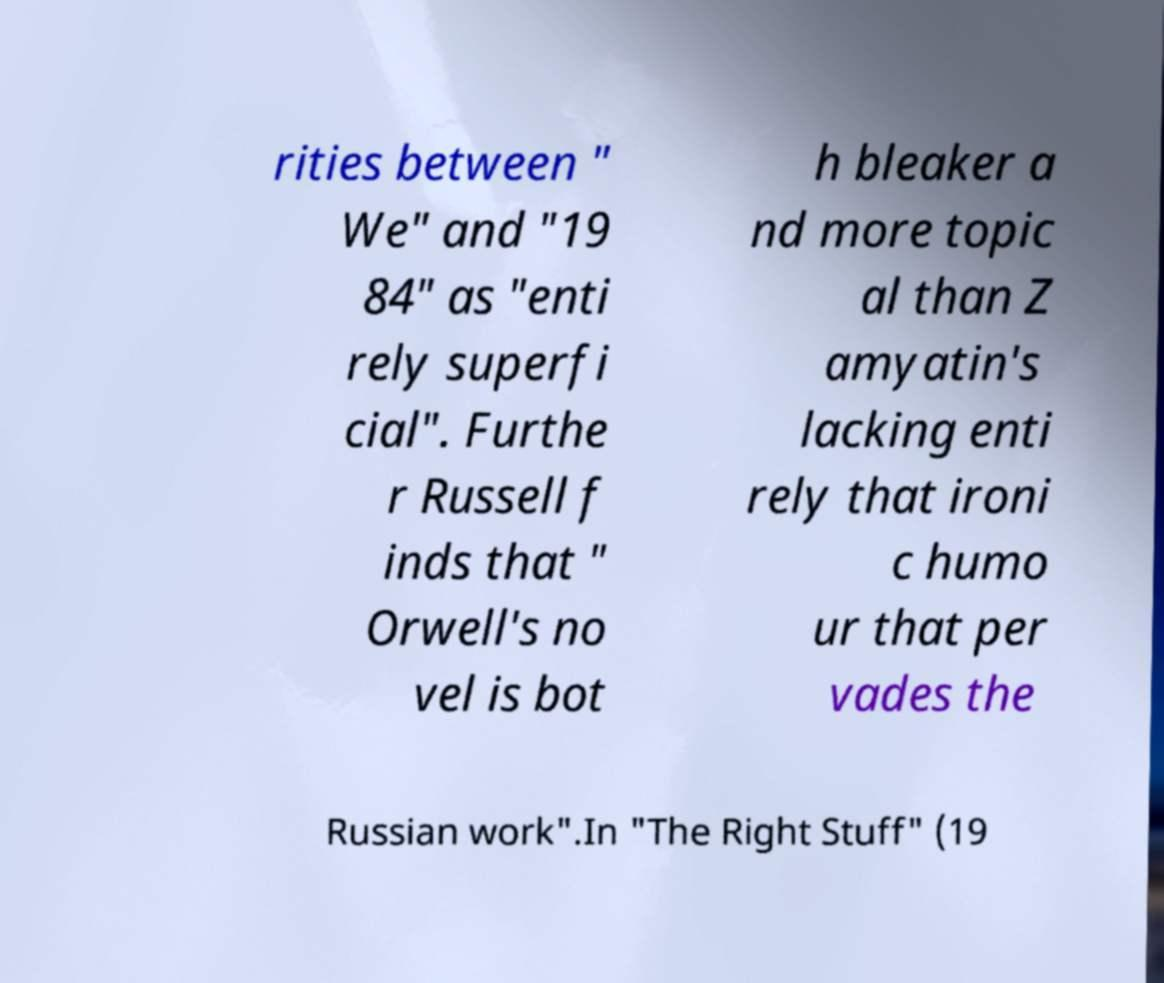Please identify and transcribe the text found in this image. rities between " We" and "19 84" as "enti rely superfi cial". Furthe r Russell f inds that " Orwell's no vel is bot h bleaker a nd more topic al than Z amyatin's lacking enti rely that ironi c humo ur that per vades the Russian work".In "The Right Stuff" (19 